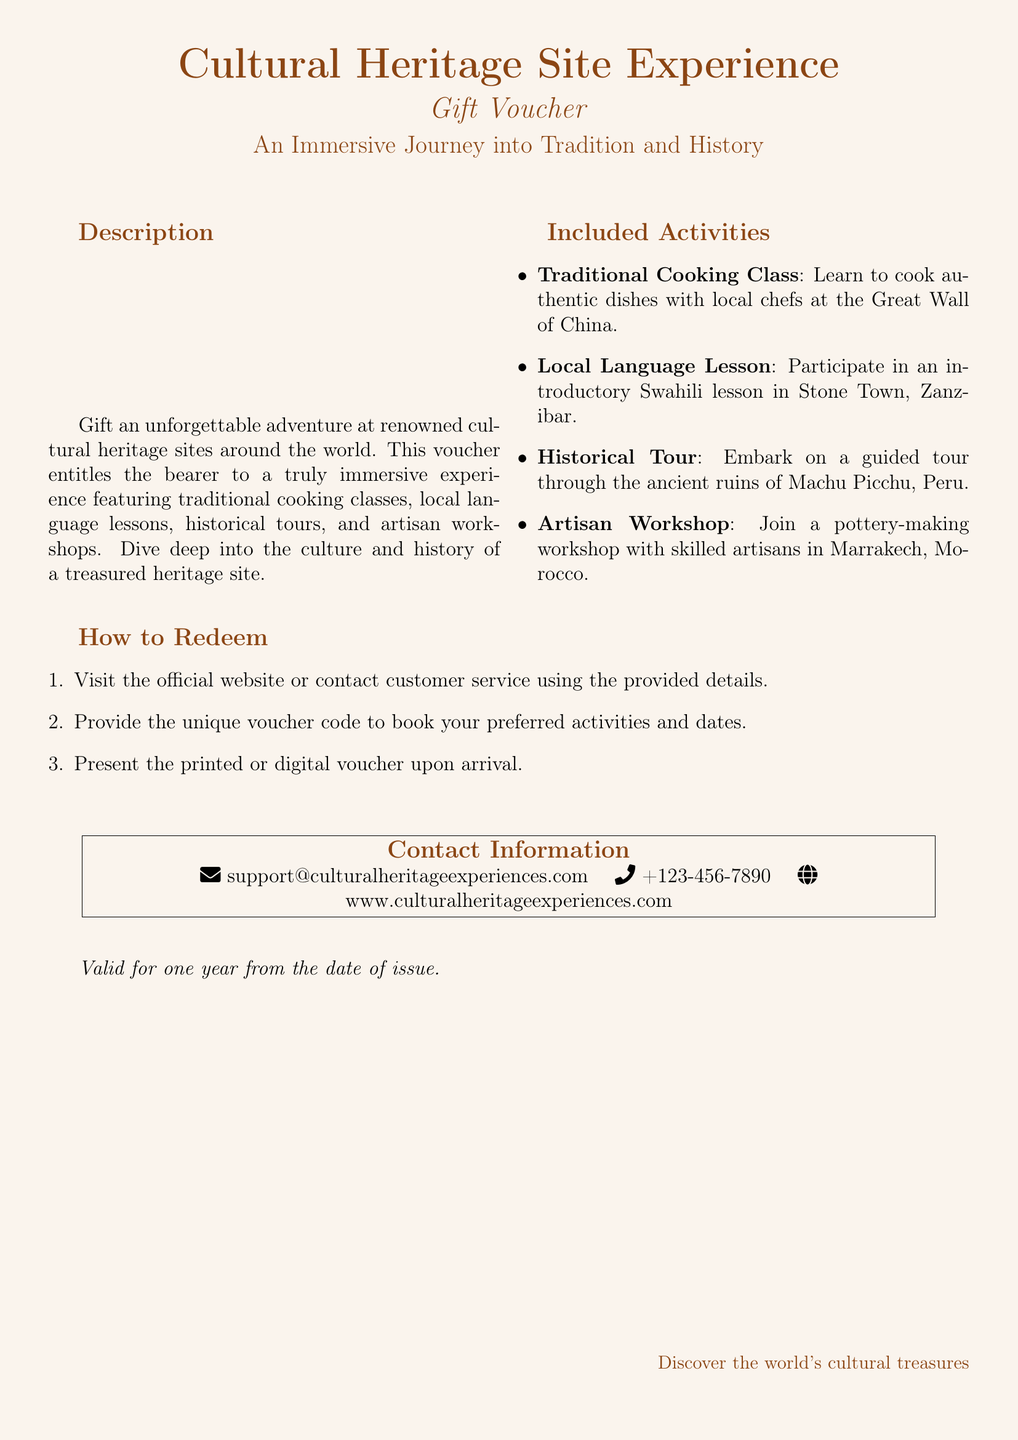What is the title of the gift voucher? The title is prominently displayed at the top of the document, indicating the purpose of the voucher.
Answer: Cultural Heritage Site Experience What activities are included in the voucher? The document lists specific activities that can be enjoyed with this voucher.
Answer: Traditional Cooking Class, Local Language Lesson, Historical Tour, Artisan Workshop How long is the voucher valid for? The validity period is noted at the bottom of the document, specifying the time limit for use.
Answer: One year What is the email contact for support? The support information includes an email address for inquiries.
Answer: support@culturalheritageexperiences.com Which historical site is associated with the cooking class? The cooking class is linked to a specific cultural landmark mentioned in the activities section.
Answer: Great Wall of China What type of lesson is offered in Stone Town? The document specifies a language lesson provided as part of the activities.
Answer: Swahili lesson What should you present upon arrival? The redemption instructions indicate what must be shown at the heritage site.
Answer: Printed or digital voucher What is the website for more information? The contact information includes a URL for accessing further details about the experiences.
Answer: www.culturalheritageexperiences.com What type of document is this? The format and content clearly categorize the document as a promotional tool for travel experiences.
Answer: Gift voucher 